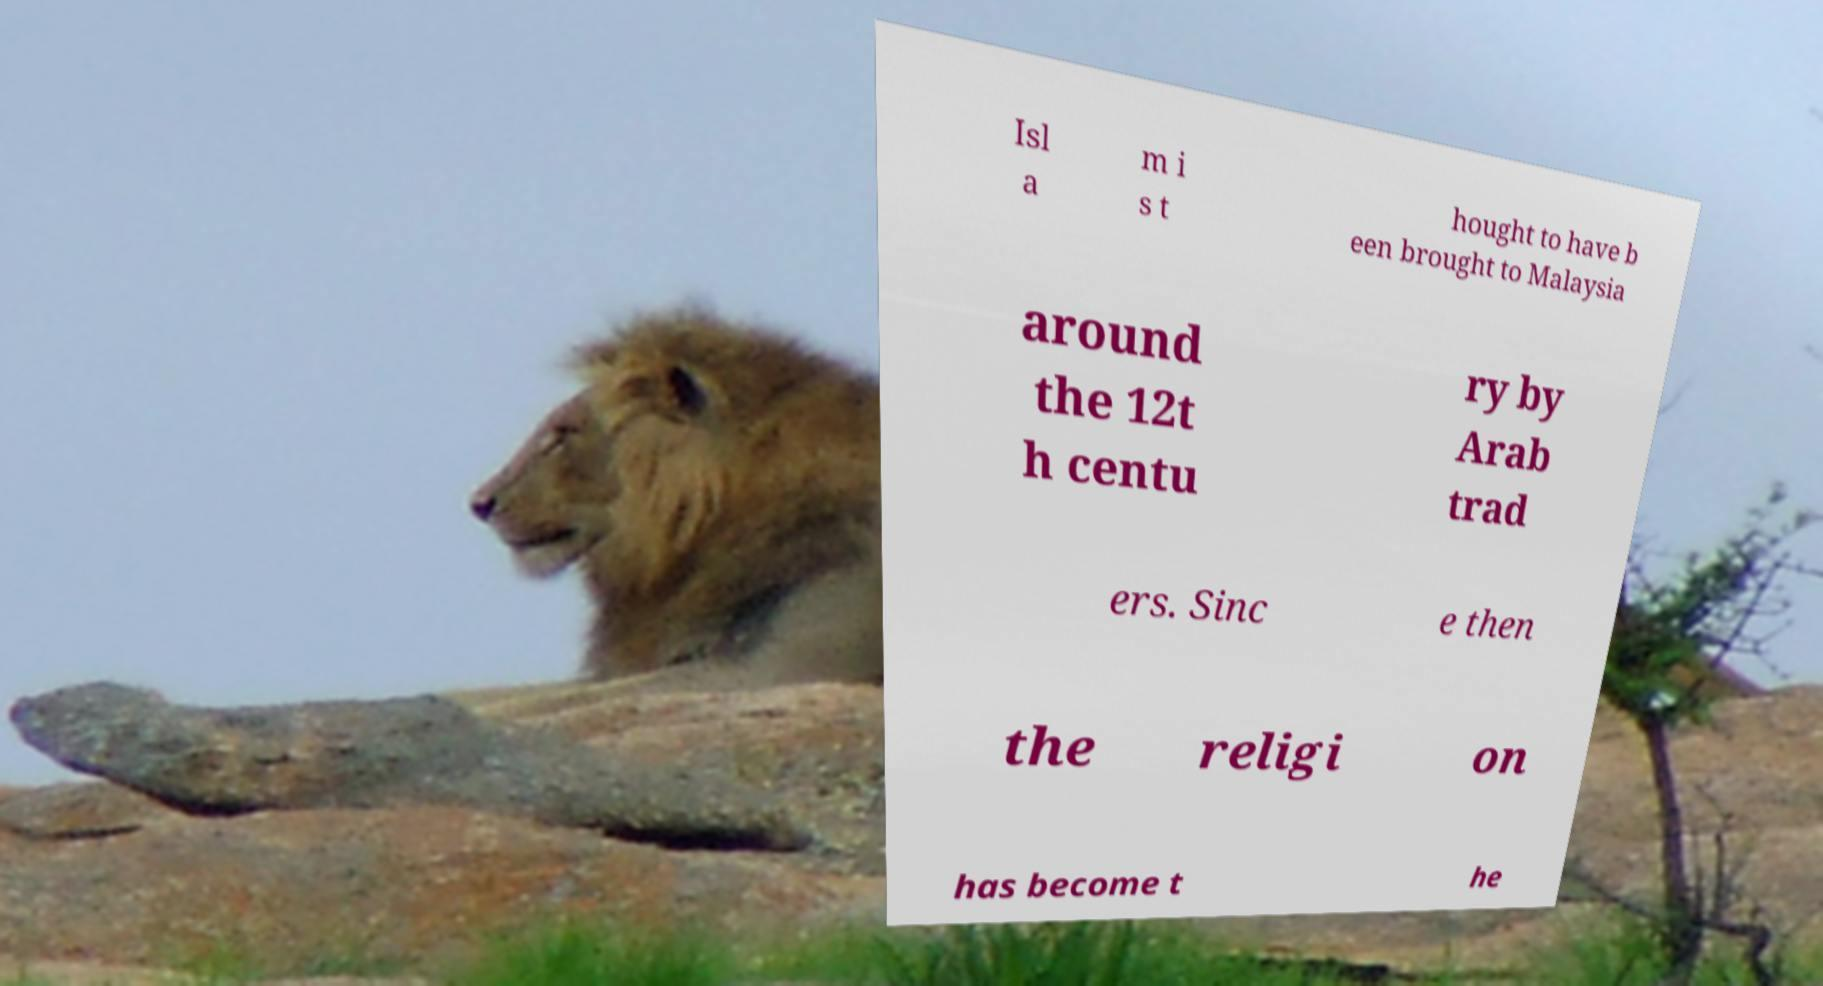There's text embedded in this image that I need extracted. Can you transcribe it verbatim? Isl a m i s t hought to have b een brought to Malaysia around the 12t h centu ry by Arab trad ers. Sinc e then the religi on has become t he 